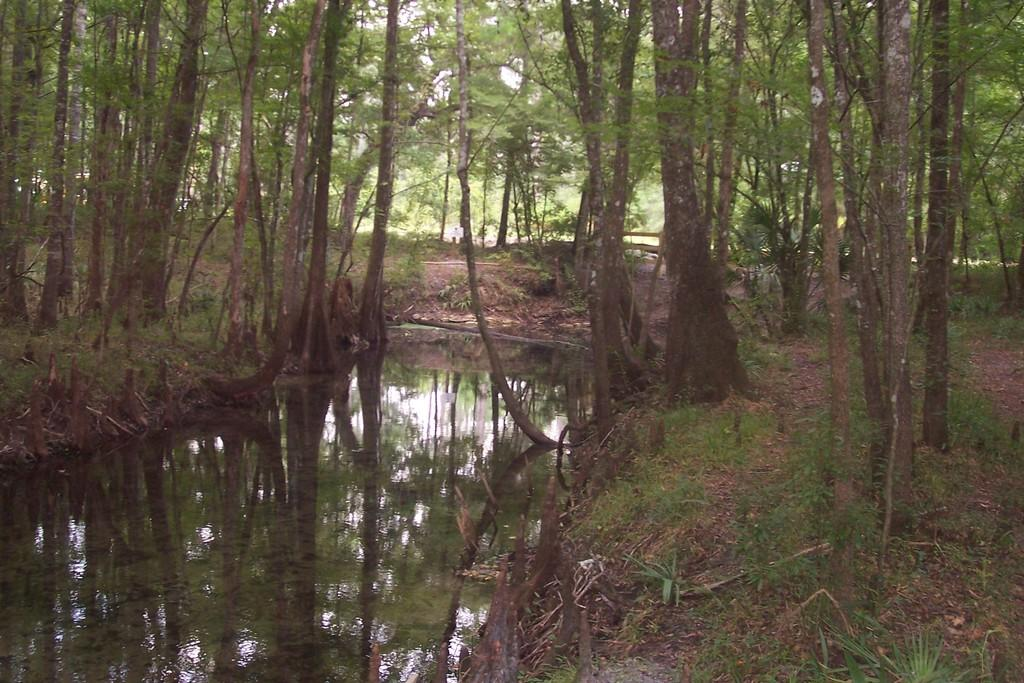What is the primary element visible in the image? There is water in the image. What type of vegetation is present alongside the water? There are trees on the sides of the water. What other types of plants can be seen in the image? There are plants in the image. What type of ground cover is visible in the image? There is grass in the image. What type of business is being conducted near the water in the image? There is no indication of any business activity in the image; it primarily features natural elements such as water, trees, plants, and grass. 